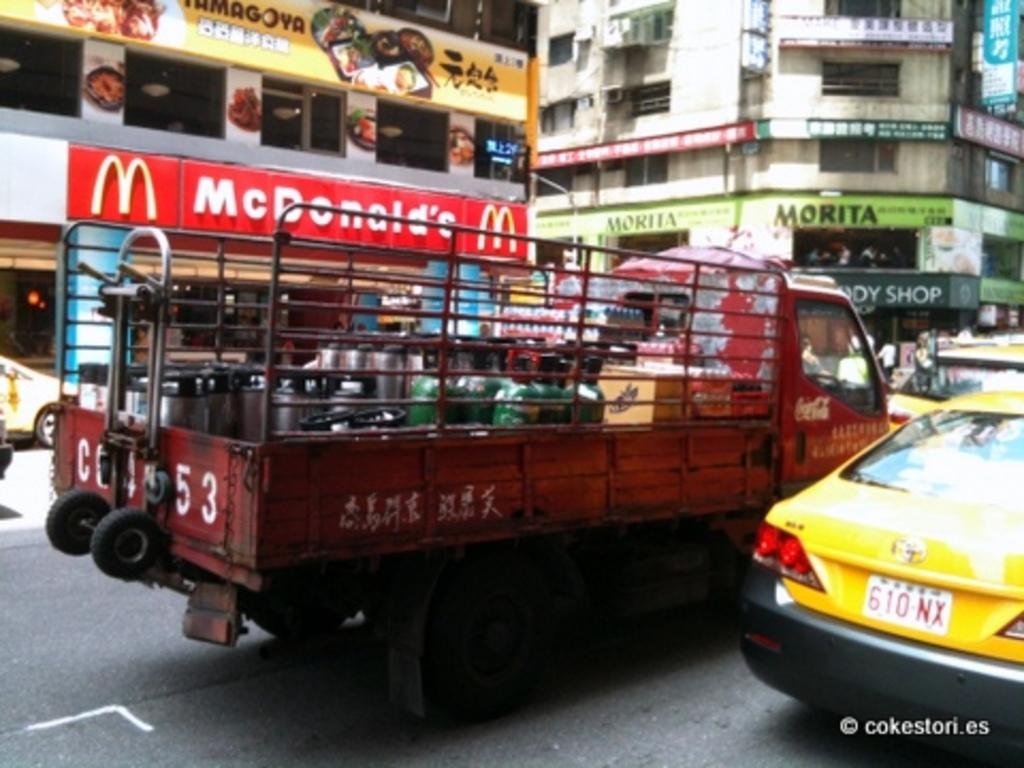<image>
Render a clear and concise summary of the photo. Mcdonald's is located on the left side of the red truck. 